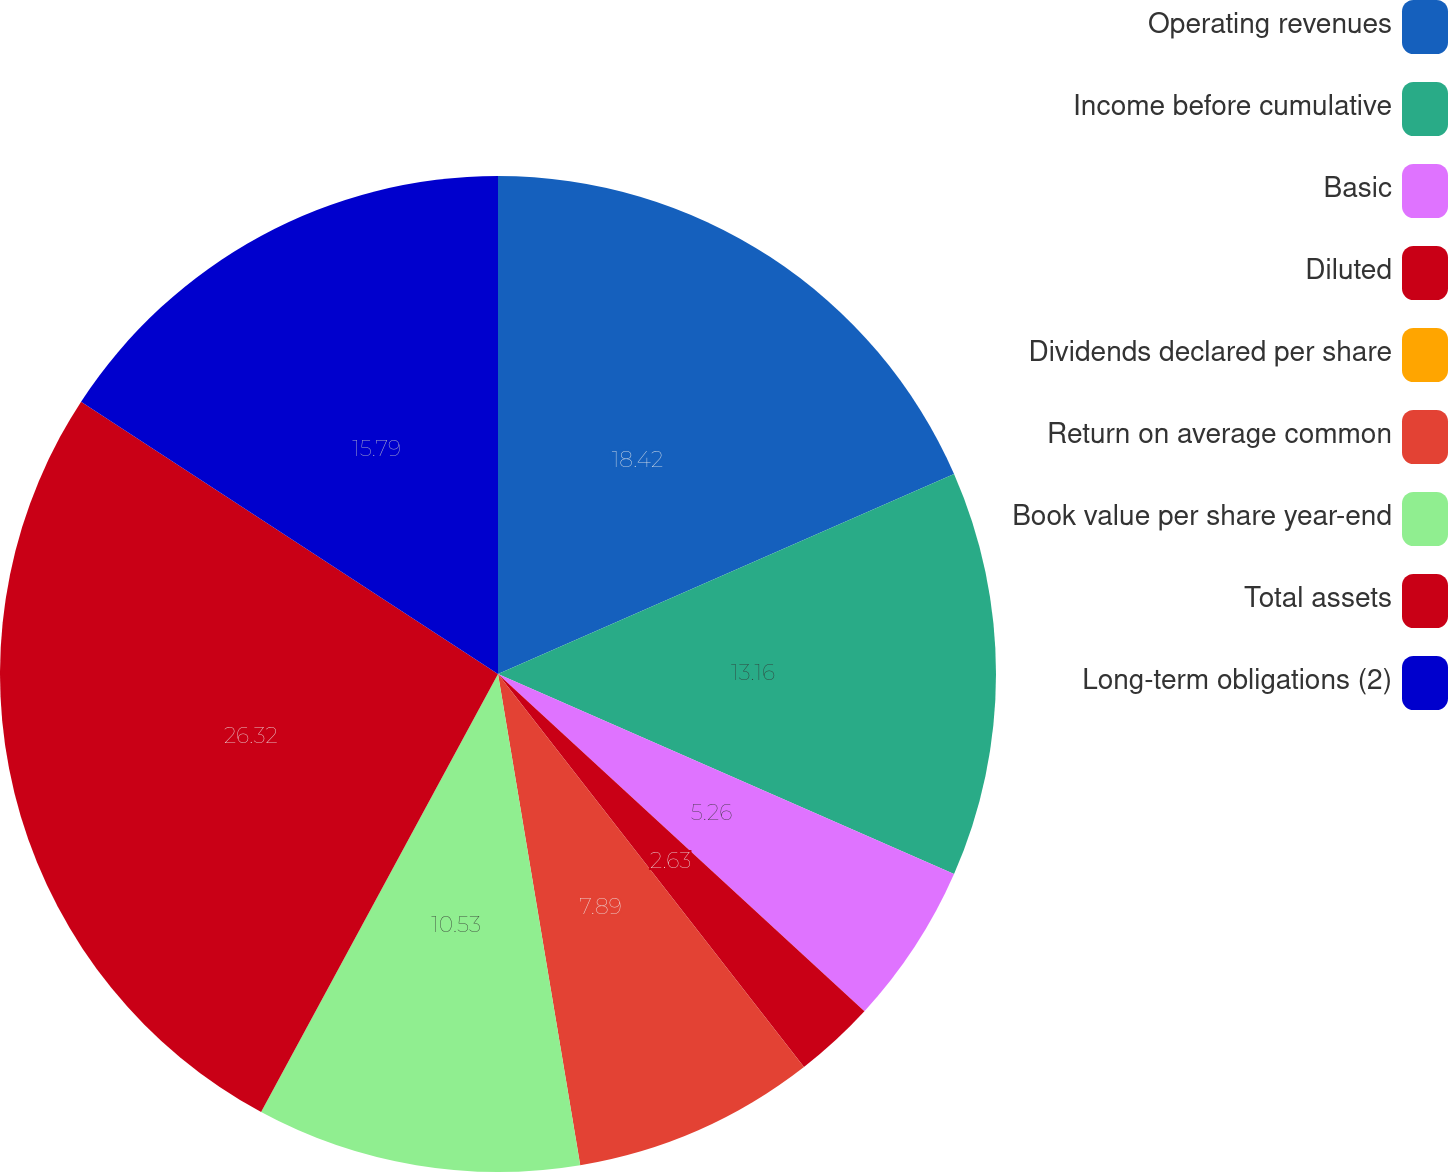<chart> <loc_0><loc_0><loc_500><loc_500><pie_chart><fcel>Operating revenues<fcel>Income before cumulative<fcel>Basic<fcel>Diluted<fcel>Dividends declared per share<fcel>Return on average common<fcel>Book value per share year-end<fcel>Total assets<fcel>Long-term obligations (2)<nl><fcel>18.42%<fcel>13.16%<fcel>5.26%<fcel>2.63%<fcel>0.0%<fcel>7.89%<fcel>10.53%<fcel>26.32%<fcel>15.79%<nl></chart> 